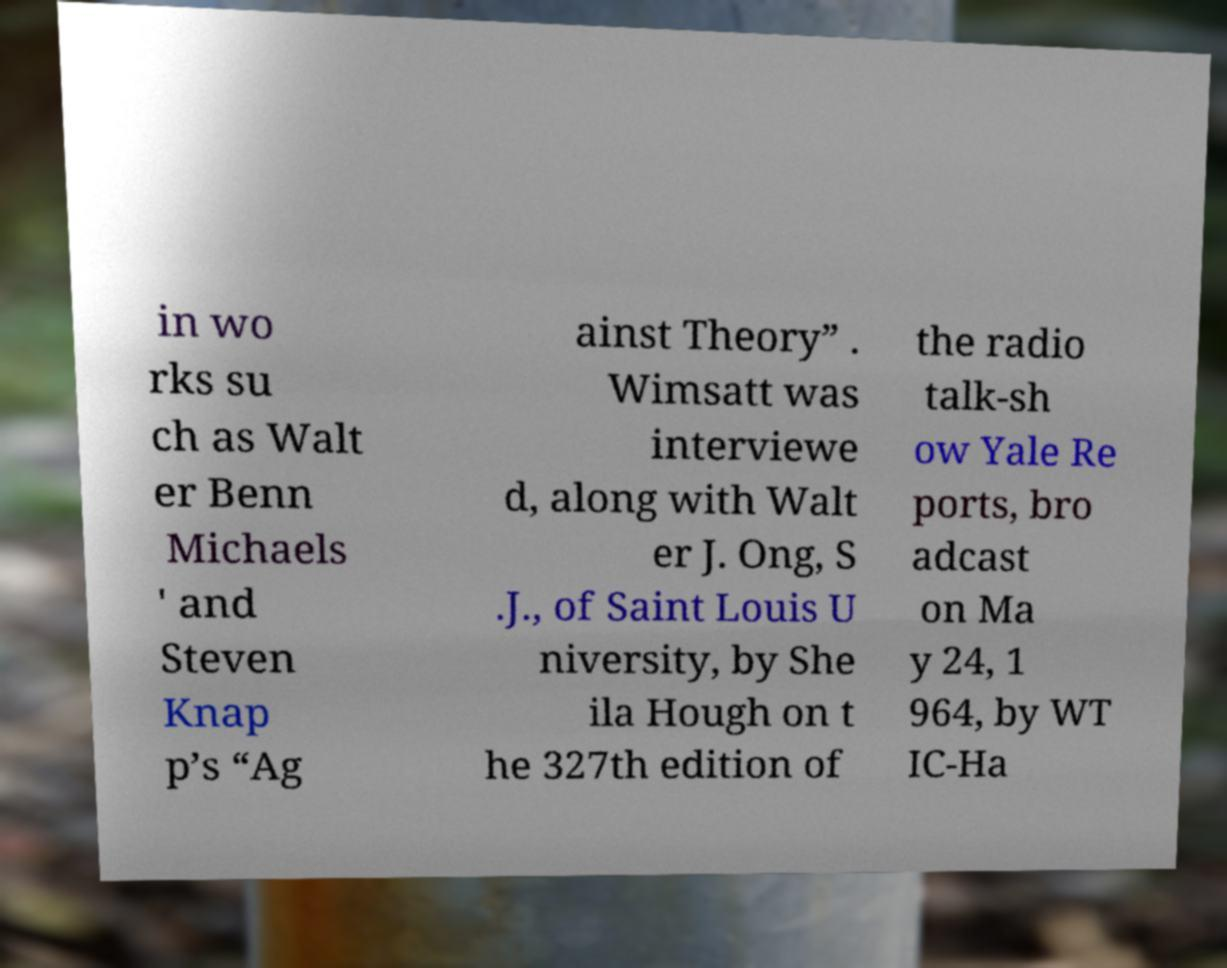There's text embedded in this image that I need extracted. Can you transcribe it verbatim? in wo rks su ch as Walt er Benn Michaels ' and Steven Knap p’s “Ag ainst Theory” . Wimsatt was interviewe d, along with Walt er J. Ong, S .J., of Saint Louis U niversity, by She ila Hough on t he 327th edition of the radio talk-sh ow Yale Re ports, bro adcast on Ma y 24, 1 964, by WT IC-Ha 